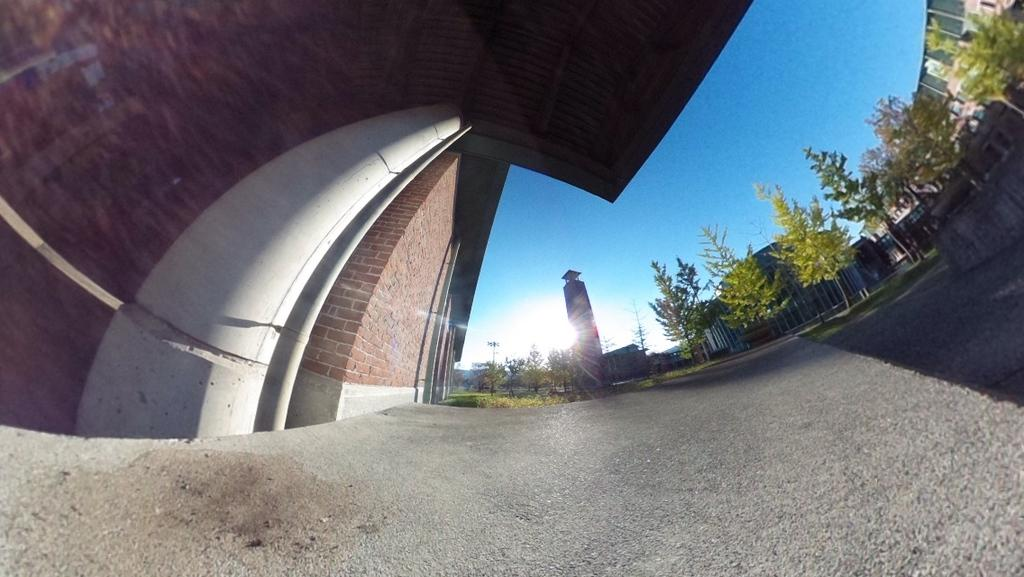What is the main structure in the middle of the picture? There is a building in the middle of the picture. What type of vegetation can be seen on the right side of the picture? There are trees on the right side of the picture. What is visible in the background of the picture? The sky is visible in the background of the picture. How many cannons are present in the picture? There are no cannons present in the picture. What type of knot is used to secure the trees in the picture? There are no knots or ropes securing the trees in the picture; they are standing on their own. 